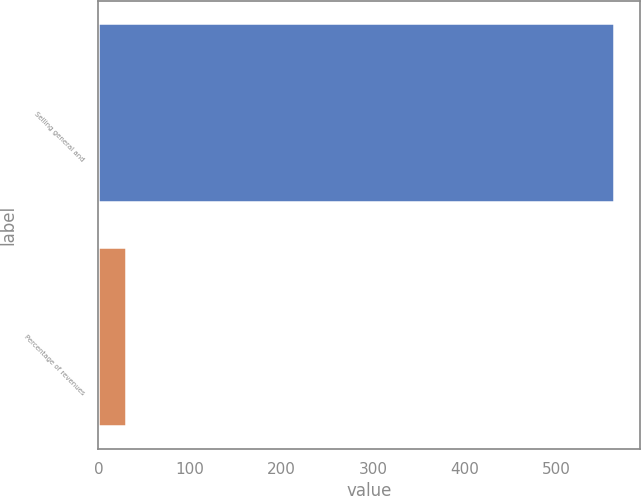Convert chart. <chart><loc_0><loc_0><loc_500><loc_500><bar_chart><fcel>Selling general and<fcel>Percentage of revenues<nl><fcel>563.3<fcel>30.2<nl></chart> 